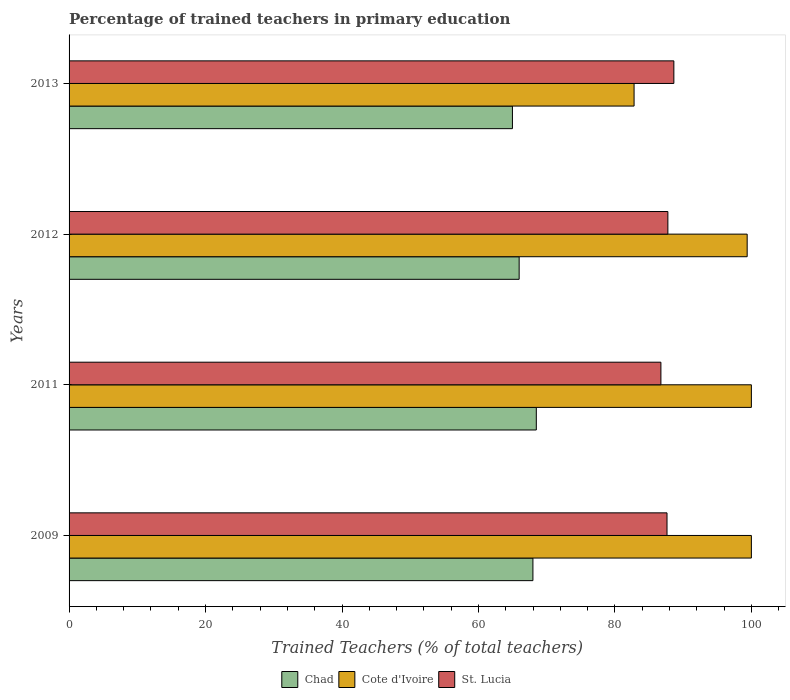How many groups of bars are there?
Give a very brief answer. 4. Are the number of bars on each tick of the Y-axis equal?
Give a very brief answer. Yes. How many bars are there on the 3rd tick from the top?
Your answer should be compact. 3. How many bars are there on the 1st tick from the bottom?
Your answer should be very brief. 3. In how many cases, is the number of bars for a given year not equal to the number of legend labels?
Give a very brief answer. 0. What is the percentage of trained teachers in St. Lucia in 2011?
Offer a very short reply. 86.74. Across all years, what is the maximum percentage of trained teachers in St. Lucia?
Provide a short and direct response. 88.64. Across all years, what is the minimum percentage of trained teachers in Chad?
Keep it short and to the point. 64.98. In which year was the percentage of trained teachers in St. Lucia minimum?
Your answer should be compact. 2011. What is the total percentage of trained teachers in Chad in the graph?
Your answer should be compact. 267.41. What is the difference between the percentage of trained teachers in St. Lucia in 2009 and that in 2013?
Ensure brevity in your answer.  -1. What is the difference between the percentage of trained teachers in St. Lucia in 2009 and the percentage of trained teachers in Chad in 2011?
Ensure brevity in your answer.  19.16. What is the average percentage of trained teachers in St. Lucia per year?
Give a very brief answer. 87.69. In the year 2011, what is the difference between the percentage of trained teachers in Chad and percentage of trained teachers in Cote d'Ivoire?
Keep it short and to the point. -31.52. What is the ratio of the percentage of trained teachers in Cote d'Ivoire in 2012 to that in 2013?
Make the answer very short. 1.2. Is the percentage of trained teachers in Chad in 2009 less than that in 2011?
Your response must be concise. Yes. Is the difference between the percentage of trained teachers in Chad in 2009 and 2012 greater than the difference between the percentage of trained teachers in Cote d'Ivoire in 2009 and 2012?
Provide a short and direct response. Yes. What is the difference between the highest and the second highest percentage of trained teachers in St. Lucia?
Make the answer very short. 0.88. What is the difference between the highest and the lowest percentage of trained teachers in Chad?
Provide a short and direct response. 3.5. Is the sum of the percentage of trained teachers in Chad in 2009 and 2012 greater than the maximum percentage of trained teachers in St. Lucia across all years?
Offer a terse response. Yes. What does the 2nd bar from the top in 2012 represents?
Offer a terse response. Cote d'Ivoire. What does the 3rd bar from the bottom in 2012 represents?
Your answer should be very brief. St. Lucia. Is it the case that in every year, the sum of the percentage of trained teachers in St. Lucia and percentage of trained teachers in Cote d'Ivoire is greater than the percentage of trained teachers in Chad?
Your response must be concise. Yes. How many bars are there?
Make the answer very short. 12. Are all the bars in the graph horizontal?
Keep it short and to the point. Yes. Are the values on the major ticks of X-axis written in scientific E-notation?
Provide a succinct answer. No. Does the graph contain any zero values?
Your answer should be compact. No. Where does the legend appear in the graph?
Offer a terse response. Bottom center. How are the legend labels stacked?
Keep it short and to the point. Horizontal. What is the title of the graph?
Your answer should be compact. Percentage of trained teachers in primary education. Does "Tajikistan" appear as one of the legend labels in the graph?
Your answer should be very brief. No. What is the label or title of the X-axis?
Offer a terse response. Trained Teachers (% of total teachers). What is the label or title of the Y-axis?
Provide a short and direct response. Years. What is the Trained Teachers (% of total teachers) in Chad in 2009?
Your answer should be very brief. 67.98. What is the Trained Teachers (% of total teachers) in Cote d'Ivoire in 2009?
Provide a short and direct response. 100. What is the Trained Teachers (% of total teachers) in St. Lucia in 2009?
Provide a succinct answer. 87.64. What is the Trained Teachers (% of total teachers) of Chad in 2011?
Your answer should be compact. 68.48. What is the Trained Teachers (% of total teachers) of St. Lucia in 2011?
Provide a succinct answer. 86.74. What is the Trained Teachers (% of total teachers) in Chad in 2012?
Make the answer very short. 65.97. What is the Trained Teachers (% of total teachers) in Cote d'Ivoire in 2012?
Make the answer very short. 99.38. What is the Trained Teachers (% of total teachers) in St. Lucia in 2012?
Make the answer very short. 87.76. What is the Trained Teachers (% of total teachers) in Chad in 2013?
Offer a terse response. 64.98. What is the Trained Teachers (% of total teachers) in Cote d'Ivoire in 2013?
Make the answer very short. 82.81. What is the Trained Teachers (% of total teachers) in St. Lucia in 2013?
Keep it short and to the point. 88.64. Across all years, what is the maximum Trained Teachers (% of total teachers) in Chad?
Keep it short and to the point. 68.48. Across all years, what is the maximum Trained Teachers (% of total teachers) in Cote d'Ivoire?
Provide a succinct answer. 100. Across all years, what is the maximum Trained Teachers (% of total teachers) in St. Lucia?
Offer a terse response. 88.64. Across all years, what is the minimum Trained Teachers (% of total teachers) in Chad?
Offer a very short reply. 64.98. Across all years, what is the minimum Trained Teachers (% of total teachers) in Cote d'Ivoire?
Offer a very short reply. 82.81. Across all years, what is the minimum Trained Teachers (% of total teachers) in St. Lucia?
Your answer should be very brief. 86.74. What is the total Trained Teachers (% of total teachers) in Chad in the graph?
Offer a terse response. 267.41. What is the total Trained Teachers (% of total teachers) of Cote d'Ivoire in the graph?
Your answer should be very brief. 382.19. What is the total Trained Teachers (% of total teachers) in St. Lucia in the graph?
Your response must be concise. 350.78. What is the difference between the Trained Teachers (% of total teachers) in Chad in 2009 and that in 2011?
Offer a very short reply. -0.5. What is the difference between the Trained Teachers (% of total teachers) in St. Lucia in 2009 and that in 2011?
Provide a succinct answer. 0.89. What is the difference between the Trained Teachers (% of total teachers) in Chad in 2009 and that in 2012?
Provide a short and direct response. 2.02. What is the difference between the Trained Teachers (% of total teachers) in Cote d'Ivoire in 2009 and that in 2012?
Ensure brevity in your answer.  0.62. What is the difference between the Trained Teachers (% of total teachers) in St. Lucia in 2009 and that in 2012?
Your response must be concise. -0.12. What is the difference between the Trained Teachers (% of total teachers) of Chad in 2009 and that in 2013?
Provide a succinct answer. 3. What is the difference between the Trained Teachers (% of total teachers) in Cote d'Ivoire in 2009 and that in 2013?
Offer a very short reply. 17.19. What is the difference between the Trained Teachers (% of total teachers) of St. Lucia in 2009 and that in 2013?
Offer a terse response. -1. What is the difference between the Trained Teachers (% of total teachers) in Chad in 2011 and that in 2012?
Offer a very short reply. 2.51. What is the difference between the Trained Teachers (% of total teachers) of Cote d'Ivoire in 2011 and that in 2012?
Make the answer very short. 0.62. What is the difference between the Trained Teachers (% of total teachers) in St. Lucia in 2011 and that in 2012?
Your answer should be very brief. -1.02. What is the difference between the Trained Teachers (% of total teachers) in Chad in 2011 and that in 2013?
Your answer should be very brief. 3.5. What is the difference between the Trained Teachers (% of total teachers) of Cote d'Ivoire in 2011 and that in 2013?
Keep it short and to the point. 17.19. What is the difference between the Trained Teachers (% of total teachers) of St. Lucia in 2011 and that in 2013?
Offer a very short reply. -1.9. What is the difference between the Trained Teachers (% of total teachers) in Chad in 2012 and that in 2013?
Ensure brevity in your answer.  0.99. What is the difference between the Trained Teachers (% of total teachers) of Cote d'Ivoire in 2012 and that in 2013?
Offer a very short reply. 16.58. What is the difference between the Trained Teachers (% of total teachers) of St. Lucia in 2012 and that in 2013?
Provide a succinct answer. -0.88. What is the difference between the Trained Teachers (% of total teachers) in Chad in 2009 and the Trained Teachers (% of total teachers) in Cote d'Ivoire in 2011?
Ensure brevity in your answer.  -32.02. What is the difference between the Trained Teachers (% of total teachers) of Chad in 2009 and the Trained Teachers (% of total teachers) of St. Lucia in 2011?
Give a very brief answer. -18.76. What is the difference between the Trained Teachers (% of total teachers) of Cote d'Ivoire in 2009 and the Trained Teachers (% of total teachers) of St. Lucia in 2011?
Offer a terse response. 13.26. What is the difference between the Trained Teachers (% of total teachers) in Chad in 2009 and the Trained Teachers (% of total teachers) in Cote d'Ivoire in 2012?
Ensure brevity in your answer.  -31.4. What is the difference between the Trained Teachers (% of total teachers) of Chad in 2009 and the Trained Teachers (% of total teachers) of St. Lucia in 2012?
Offer a terse response. -19.78. What is the difference between the Trained Teachers (% of total teachers) in Cote d'Ivoire in 2009 and the Trained Teachers (% of total teachers) in St. Lucia in 2012?
Give a very brief answer. 12.24. What is the difference between the Trained Teachers (% of total teachers) in Chad in 2009 and the Trained Teachers (% of total teachers) in Cote d'Ivoire in 2013?
Provide a succinct answer. -14.83. What is the difference between the Trained Teachers (% of total teachers) of Chad in 2009 and the Trained Teachers (% of total teachers) of St. Lucia in 2013?
Offer a very short reply. -20.66. What is the difference between the Trained Teachers (% of total teachers) of Cote d'Ivoire in 2009 and the Trained Teachers (% of total teachers) of St. Lucia in 2013?
Ensure brevity in your answer.  11.36. What is the difference between the Trained Teachers (% of total teachers) in Chad in 2011 and the Trained Teachers (% of total teachers) in Cote d'Ivoire in 2012?
Ensure brevity in your answer.  -30.9. What is the difference between the Trained Teachers (% of total teachers) of Chad in 2011 and the Trained Teachers (% of total teachers) of St. Lucia in 2012?
Keep it short and to the point. -19.28. What is the difference between the Trained Teachers (% of total teachers) in Cote d'Ivoire in 2011 and the Trained Teachers (% of total teachers) in St. Lucia in 2012?
Your answer should be very brief. 12.24. What is the difference between the Trained Teachers (% of total teachers) of Chad in 2011 and the Trained Teachers (% of total teachers) of Cote d'Ivoire in 2013?
Your answer should be compact. -14.33. What is the difference between the Trained Teachers (% of total teachers) in Chad in 2011 and the Trained Teachers (% of total teachers) in St. Lucia in 2013?
Your response must be concise. -20.16. What is the difference between the Trained Teachers (% of total teachers) in Cote d'Ivoire in 2011 and the Trained Teachers (% of total teachers) in St. Lucia in 2013?
Your response must be concise. 11.36. What is the difference between the Trained Teachers (% of total teachers) in Chad in 2012 and the Trained Teachers (% of total teachers) in Cote d'Ivoire in 2013?
Ensure brevity in your answer.  -16.84. What is the difference between the Trained Teachers (% of total teachers) of Chad in 2012 and the Trained Teachers (% of total teachers) of St. Lucia in 2013?
Your response must be concise. -22.67. What is the difference between the Trained Teachers (% of total teachers) in Cote d'Ivoire in 2012 and the Trained Teachers (% of total teachers) in St. Lucia in 2013?
Provide a succinct answer. 10.75. What is the average Trained Teachers (% of total teachers) in Chad per year?
Ensure brevity in your answer.  66.85. What is the average Trained Teachers (% of total teachers) in Cote d'Ivoire per year?
Keep it short and to the point. 95.55. What is the average Trained Teachers (% of total teachers) of St. Lucia per year?
Ensure brevity in your answer.  87.69. In the year 2009, what is the difference between the Trained Teachers (% of total teachers) of Chad and Trained Teachers (% of total teachers) of Cote d'Ivoire?
Your answer should be compact. -32.02. In the year 2009, what is the difference between the Trained Teachers (% of total teachers) of Chad and Trained Teachers (% of total teachers) of St. Lucia?
Offer a terse response. -19.65. In the year 2009, what is the difference between the Trained Teachers (% of total teachers) in Cote d'Ivoire and Trained Teachers (% of total teachers) in St. Lucia?
Provide a succinct answer. 12.36. In the year 2011, what is the difference between the Trained Teachers (% of total teachers) in Chad and Trained Teachers (% of total teachers) in Cote d'Ivoire?
Offer a terse response. -31.52. In the year 2011, what is the difference between the Trained Teachers (% of total teachers) in Chad and Trained Teachers (% of total teachers) in St. Lucia?
Give a very brief answer. -18.26. In the year 2011, what is the difference between the Trained Teachers (% of total teachers) in Cote d'Ivoire and Trained Teachers (% of total teachers) in St. Lucia?
Make the answer very short. 13.26. In the year 2012, what is the difference between the Trained Teachers (% of total teachers) of Chad and Trained Teachers (% of total teachers) of Cote d'Ivoire?
Provide a short and direct response. -33.42. In the year 2012, what is the difference between the Trained Teachers (% of total teachers) of Chad and Trained Teachers (% of total teachers) of St. Lucia?
Make the answer very short. -21.79. In the year 2012, what is the difference between the Trained Teachers (% of total teachers) in Cote d'Ivoire and Trained Teachers (% of total teachers) in St. Lucia?
Offer a very short reply. 11.62. In the year 2013, what is the difference between the Trained Teachers (% of total teachers) in Chad and Trained Teachers (% of total teachers) in Cote d'Ivoire?
Provide a short and direct response. -17.83. In the year 2013, what is the difference between the Trained Teachers (% of total teachers) in Chad and Trained Teachers (% of total teachers) in St. Lucia?
Keep it short and to the point. -23.66. In the year 2013, what is the difference between the Trained Teachers (% of total teachers) of Cote d'Ivoire and Trained Teachers (% of total teachers) of St. Lucia?
Provide a short and direct response. -5.83. What is the ratio of the Trained Teachers (% of total teachers) of Cote d'Ivoire in 2009 to that in 2011?
Your answer should be compact. 1. What is the ratio of the Trained Teachers (% of total teachers) of St. Lucia in 2009 to that in 2011?
Your answer should be very brief. 1.01. What is the ratio of the Trained Teachers (% of total teachers) in Chad in 2009 to that in 2012?
Provide a succinct answer. 1.03. What is the ratio of the Trained Teachers (% of total teachers) in Chad in 2009 to that in 2013?
Make the answer very short. 1.05. What is the ratio of the Trained Teachers (% of total teachers) in Cote d'Ivoire in 2009 to that in 2013?
Give a very brief answer. 1.21. What is the ratio of the Trained Teachers (% of total teachers) of St. Lucia in 2009 to that in 2013?
Your answer should be very brief. 0.99. What is the ratio of the Trained Teachers (% of total teachers) of Chad in 2011 to that in 2012?
Provide a short and direct response. 1.04. What is the ratio of the Trained Teachers (% of total teachers) in Cote d'Ivoire in 2011 to that in 2012?
Your response must be concise. 1.01. What is the ratio of the Trained Teachers (% of total teachers) in St. Lucia in 2011 to that in 2012?
Provide a short and direct response. 0.99. What is the ratio of the Trained Teachers (% of total teachers) of Chad in 2011 to that in 2013?
Make the answer very short. 1.05. What is the ratio of the Trained Teachers (% of total teachers) in Cote d'Ivoire in 2011 to that in 2013?
Provide a succinct answer. 1.21. What is the ratio of the Trained Teachers (% of total teachers) of St. Lucia in 2011 to that in 2013?
Provide a short and direct response. 0.98. What is the ratio of the Trained Teachers (% of total teachers) of Chad in 2012 to that in 2013?
Provide a succinct answer. 1.02. What is the ratio of the Trained Teachers (% of total teachers) in Cote d'Ivoire in 2012 to that in 2013?
Your answer should be compact. 1.2. What is the difference between the highest and the second highest Trained Teachers (% of total teachers) in Chad?
Your answer should be very brief. 0.5. What is the difference between the highest and the second highest Trained Teachers (% of total teachers) in Cote d'Ivoire?
Keep it short and to the point. 0. What is the difference between the highest and the second highest Trained Teachers (% of total teachers) in St. Lucia?
Provide a short and direct response. 0.88. What is the difference between the highest and the lowest Trained Teachers (% of total teachers) in Chad?
Provide a short and direct response. 3.5. What is the difference between the highest and the lowest Trained Teachers (% of total teachers) of Cote d'Ivoire?
Provide a short and direct response. 17.19. What is the difference between the highest and the lowest Trained Teachers (% of total teachers) in St. Lucia?
Offer a very short reply. 1.9. 